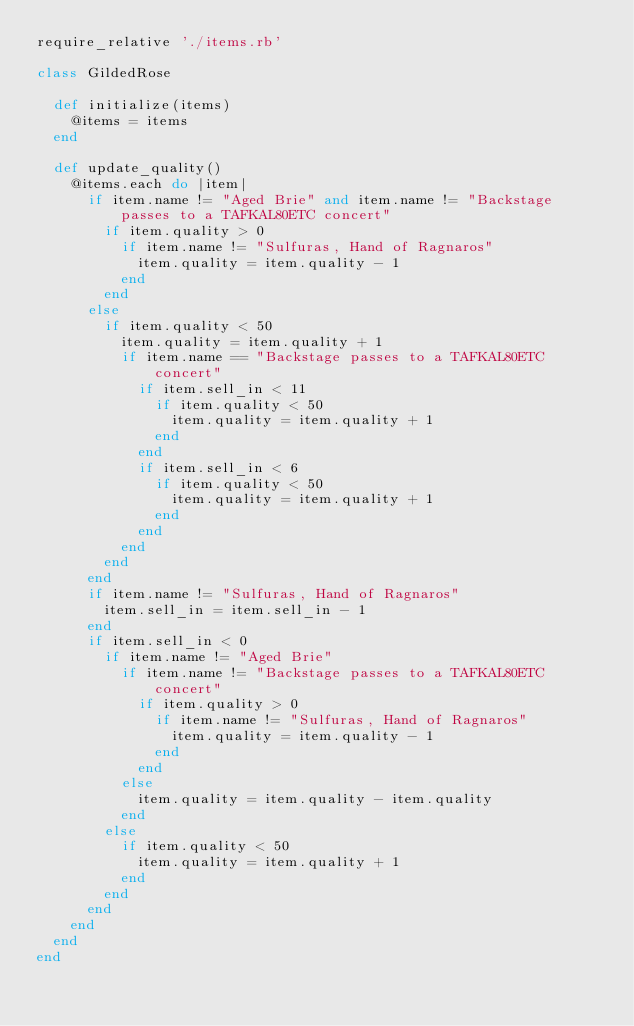Convert code to text. <code><loc_0><loc_0><loc_500><loc_500><_Ruby_>require_relative './items.rb'

class GildedRose

  def initialize(items)
    @items = items
  end

  def update_quality()
    @items.each do |item|
      if item.name != "Aged Brie" and item.name != "Backstage passes to a TAFKAL80ETC concert"
        if item.quality > 0
          if item.name != "Sulfuras, Hand of Ragnaros"
            item.quality = item.quality - 1
          end
        end
      else
        if item.quality < 50
          item.quality = item.quality + 1
          if item.name == "Backstage passes to a TAFKAL80ETC concert"
            if item.sell_in < 11
              if item.quality < 50
                item.quality = item.quality + 1
              end
            end
            if item.sell_in < 6
              if item.quality < 50
                item.quality = item.quality + 1
              end
            end
          end
        end
      end
      if item.name != "Sulfuras, Hand of Ragnaros"
        item.sell_in = item.sell_in - 1
      end
      if item.sell_in < 0
        if item.name != "Aged Brie"
          if item.name != "Backstage passes to a TAFKAL80ETC concert"
            if item.quality > 0
              if item.name != "Sulfuras, Hand of Ragnaros"
                item.quality = item.quality - 1
              end
            end
          else
            item.quality = item.quality - item.quality
          end
        else
          if item.quality < 50
            item.quality = item.quality + 1
          end
        end
      end
    end
  end
end
</code> 